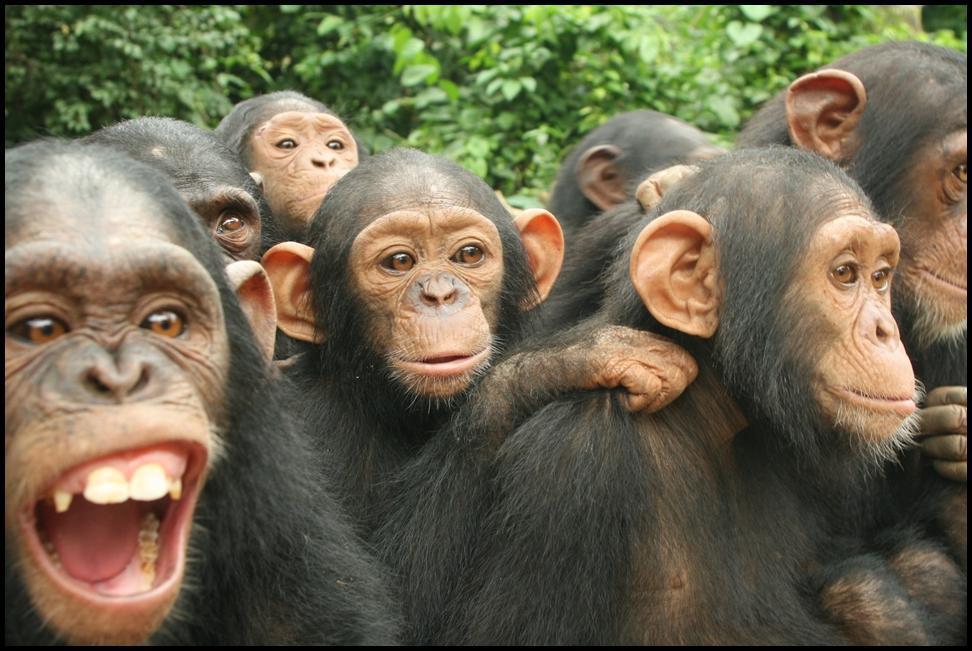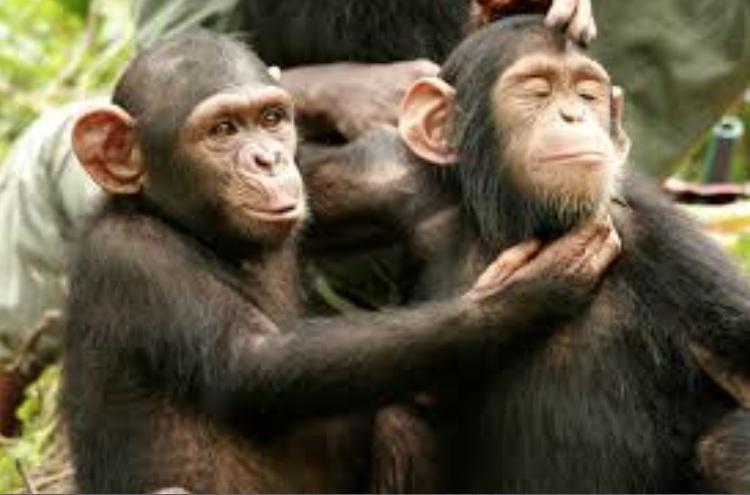The first image is the image on the left, the second image is the image on the right. Assess this claim about the two images: "Each image has two primates in the wild.". Correct or not? Answer yes or no. No. 